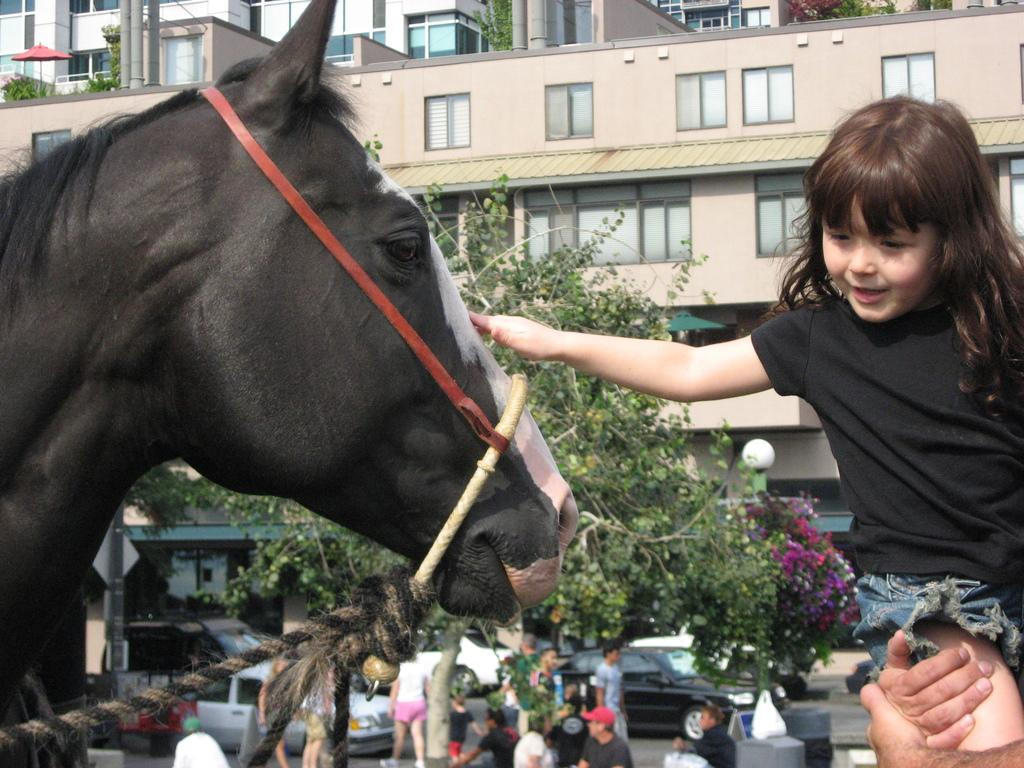Who is the main subject in the image? There is a small girl in the image. What is the girl doing in the image? The girl is touching a horse. What can be seen in the background of the image? There are plants and buildings in the background of the image. What type of suit is the horse wearing in the image? There is no suit present in the image, and horses do not wear clothing. 